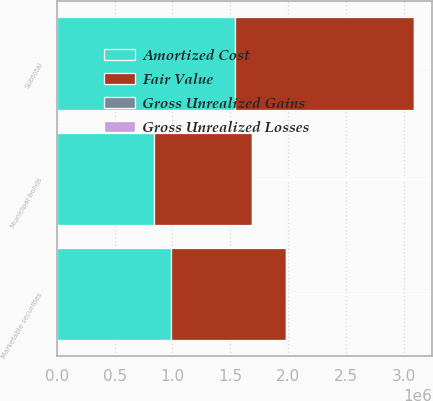Convert chart. <chart><loc_0><loc_0><loc_500><loc_500><stacked_bar_chart><ecel><fcel>Municipal bonds<fcel>Subtotal<fcel>Marketable securities<nl><fcel>Fair Value<fcel>843993<fcel>1.5455e+06<fcel>990645<nl><fcel>Gross Unrealized Gains<fcel>95<fcel>134<fcel>134<nl><fcel>Gross Unrealized Losses<fcel>2661<fcel>2661<fcel>2661<nl><fcel>Amortized Cost<fcel>841427<fcel>1.54298e+06<fcel>988118<nl></chart> 